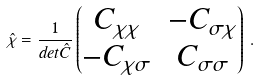<formula> <loc_0><loc_0><loc_500><loc_500>\hat { \chi } = \frac { 1 } { d e t \hat { C } } \left ( \begin{matrix} C _ { \chi \chi } & - C _ { \sigma \chi } \\ - C _ { \chi \sigma } & C _ { \sigma \sigma } \end{matrix} \right ) \, .</formula> 